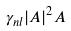<formula> <loc_0><loc_0><loc_500><loc_500>\gamma _ { n l } | A | ^ { 2 } A</formula> 